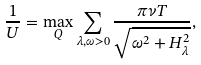Convert formula to latex. <formula><loc_0><loc_0><loc_500><loc_500>\frac { 1 } { U } = \max _ { Q } \sum _ { \lambda , \omega > 0 } \frac { \pi \nu T } { \sqrt { \omega ^ { 2 } + H _ { \lambda } ^ { 2 } } } ,</formula> 